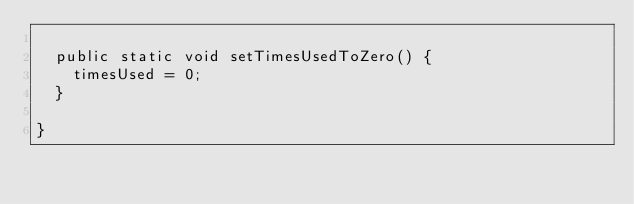<code> <loc_0><loc_0><loc_500><loc_500><_Java_>	
	public static void setTimesUsedToZero() {
		timesUsed = 0;
	}
	
}
</code> 